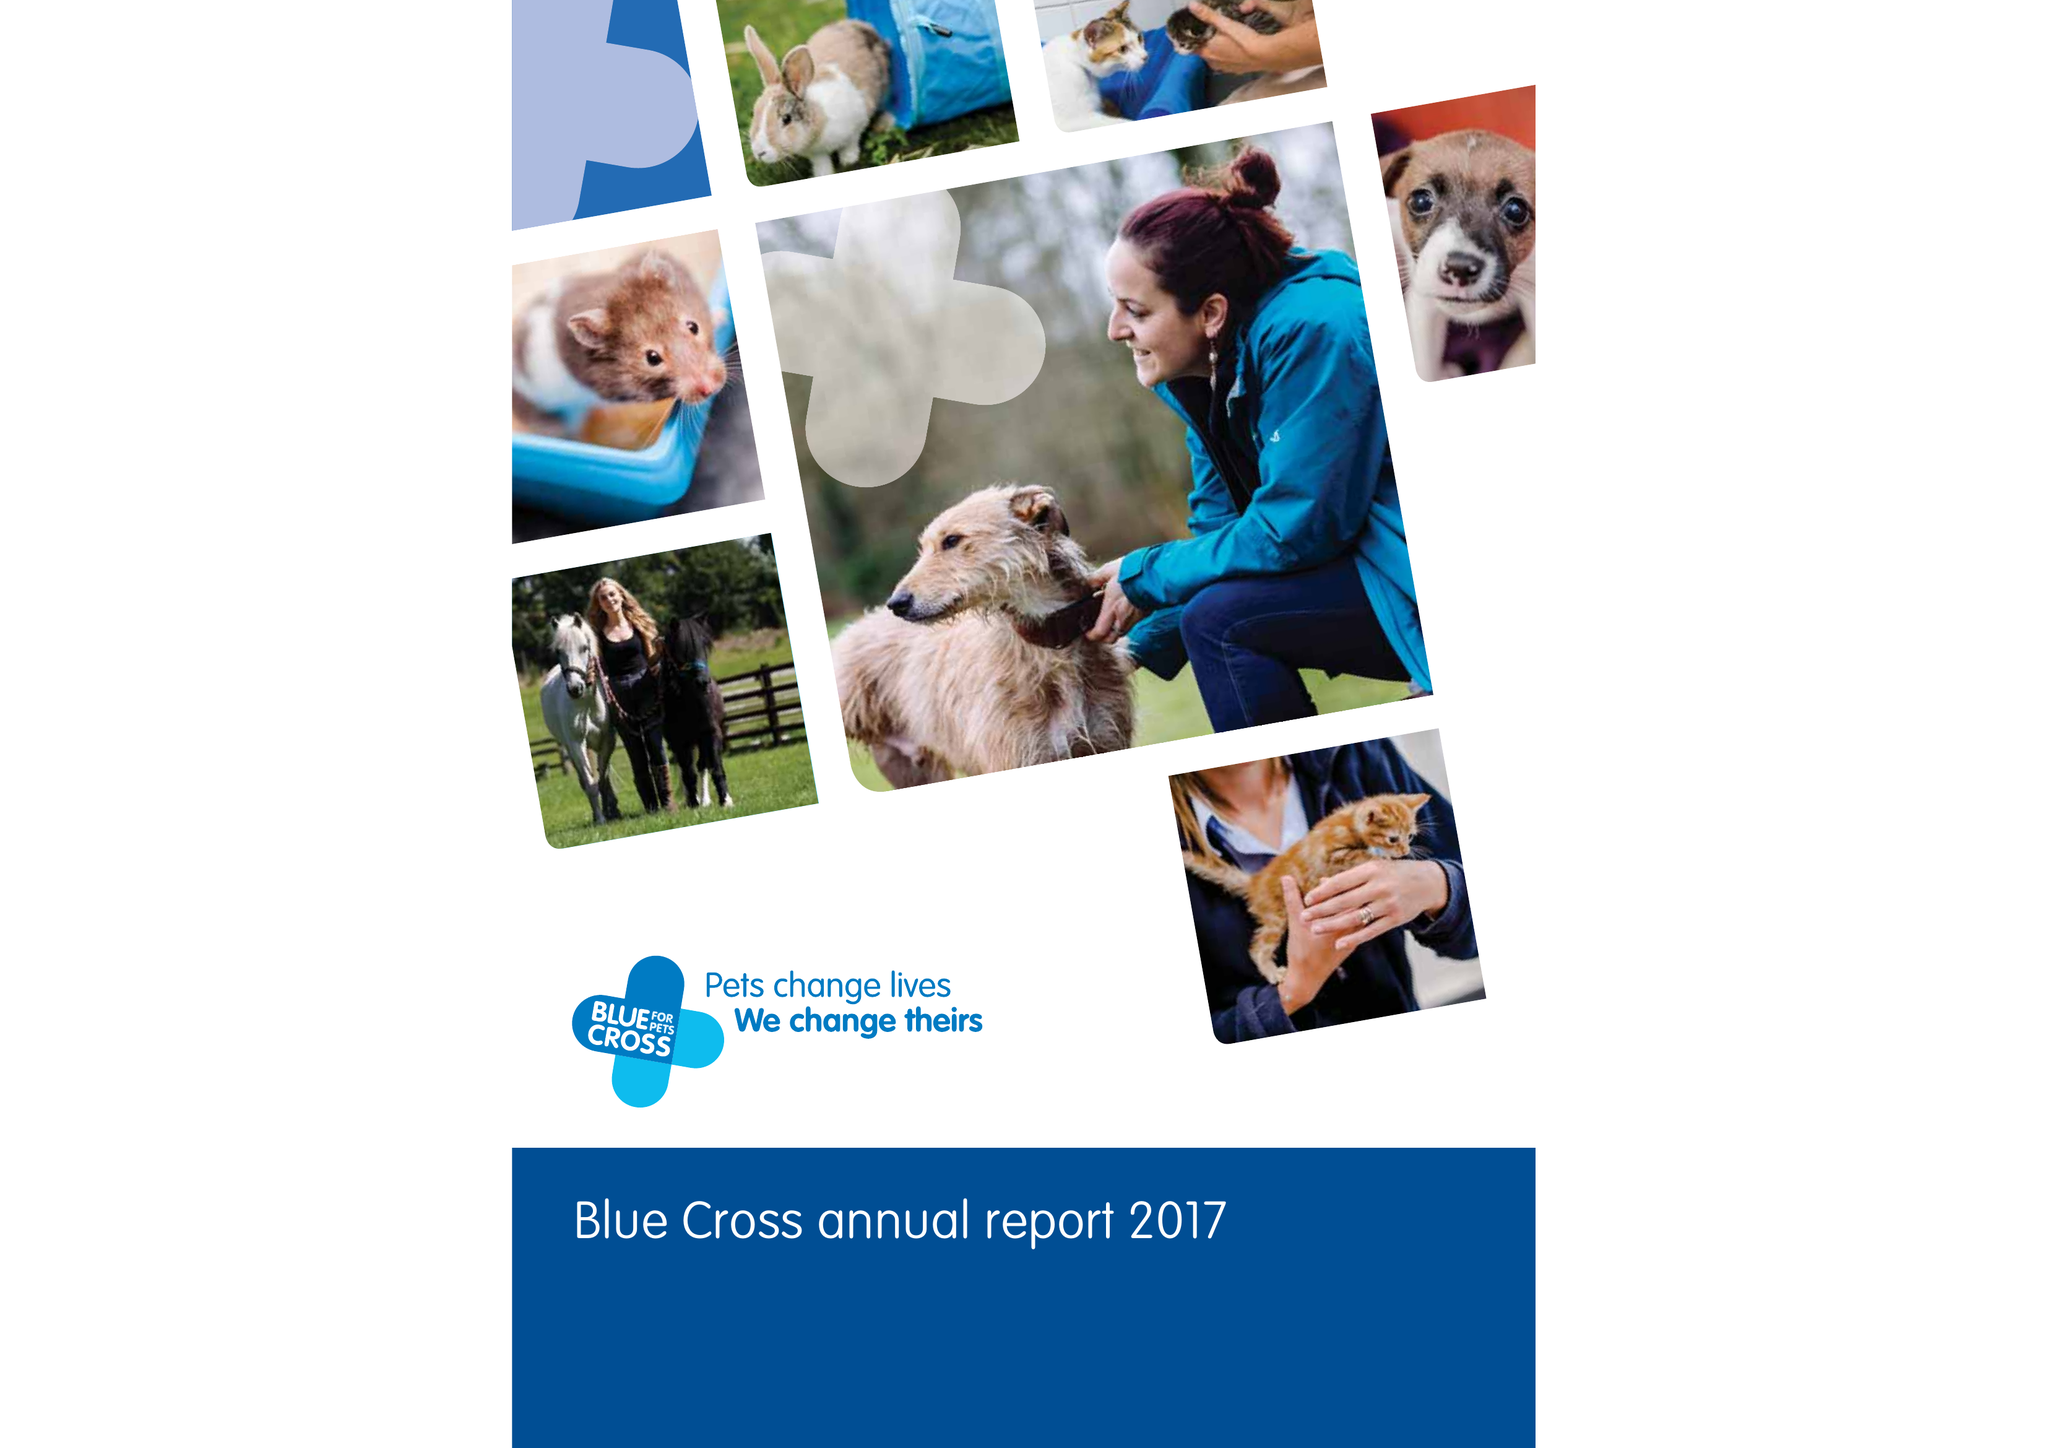What is the value for the report_date?
Answer the question using a single word or phrase. 2017-12-31 